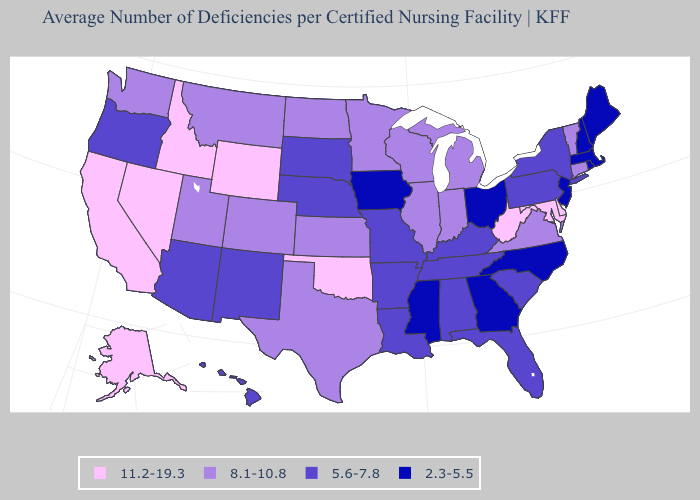Among the states that border Rhode Island , which have the highest value?
Quick response, please. Connecticut. Name the states that have a value in the range 8.1-10.8?
Keep it brief. Colorado, Connecticut, Illinois, Indiana, Kansas, Michigan, Minnesota, Montana, North Dakota, Texas, Utah, Vermont, Virginia, Washington, Wisconsin. What is the value of Connecticut?
Quick response, please. 8.1-10.8. Which states have the highest value in the USA?
Keep it brief. Alaska, California, Delaware, Idaho, Maryland, Nevada, Oklahoma, West Virginia, Wyoming. Does Nevada have the highest value in the USA?
Write a very short answer. Yes. Which states hav the highest value in the West?
Answer briefly. Alaska, California, Idaho, Nevada, Wyoming. Among the states that border North Dakota , which have the highest value?
Quick response, please. Minnesota, Montana. Among the states that border North Dakota , which have the highest value?
Quick response, please. Minnesota, Montana. What is the value of Oklahoma?
Concise answer only. 11.2-19.3. How many symbols are there in the legend?
Quick response, please. 4. What is the value of Nebraska?
Answer briefly. 5.6-7.8. Does South Carolina have the lowest value in the South?
Short answer required. No. What is the lowest value in the Northeast?
Concise answer only. 2.3-5.5. Is the legend a continuous bar?
Answer briefly. No. Name the states that have a value in the range 5.6-7.8?
Short answer required. Alabama, Arizona, Arkansas, Florida, Hawaii, Kentucky, Louisiana, Missouri, Nebraska, New Mexico, New York, Oregon, Pennsylvania, South Carolina, South Dakota, Tennessee. 